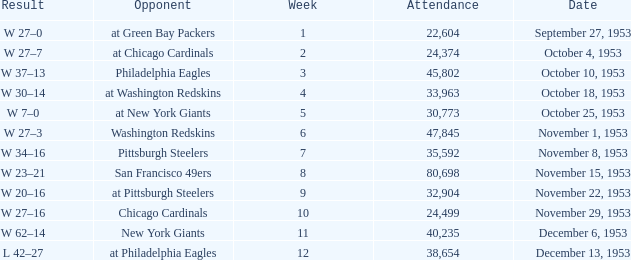Could you help me parse every detail presented in this table? {'header': ['Result', 'Opponent', 'Week', 'Attendance', 'Date'], 'rows': [['W 27–0', 'at Green Bay Packers', '1', '22,604', 'September 27, 1953'], ['W 27–7', 'at Chicago Cardinals', '2', '24,374', 'October 4, 1953'], ['W 37–13', 'Philadelphia Eagles', '3', '45,802', 'October 10, 1953'], ['W 30–14', 'at Washington Redskins', '4', '33,963', 'October 18, 1953'], ['W 7–0', 'at New York Giants', '5', '30,773', 'October 25, 1953'], ['W 27–3', 'Washington Redskins', '6', '47,845', 'November 1, 1953'], ['W 34–16', 'Pittsburgh Steelers', '7', '35,592', 'November 8, 1953'], ['W 23–21', 'San Francisco 49ers', '8', '80,698', 'November 15, 1953'], ['W 20–16', 'at Pittsburgh Steelers', '9', '32,904', 'November 22, 1953'], ['W 27–16', 'Chicago Cardinals', '10', '24,499', 'November 29, 1953'], ['W 62–14', 'New York Giants', '11', '40,235', 'December 6, 1953'], ['L 42–27', 'at Philadelphia Eagles', '12', '38,654', 'December 13, 1953']]} What is the average week number of all the matches where less than 22,604 people attended? None. 